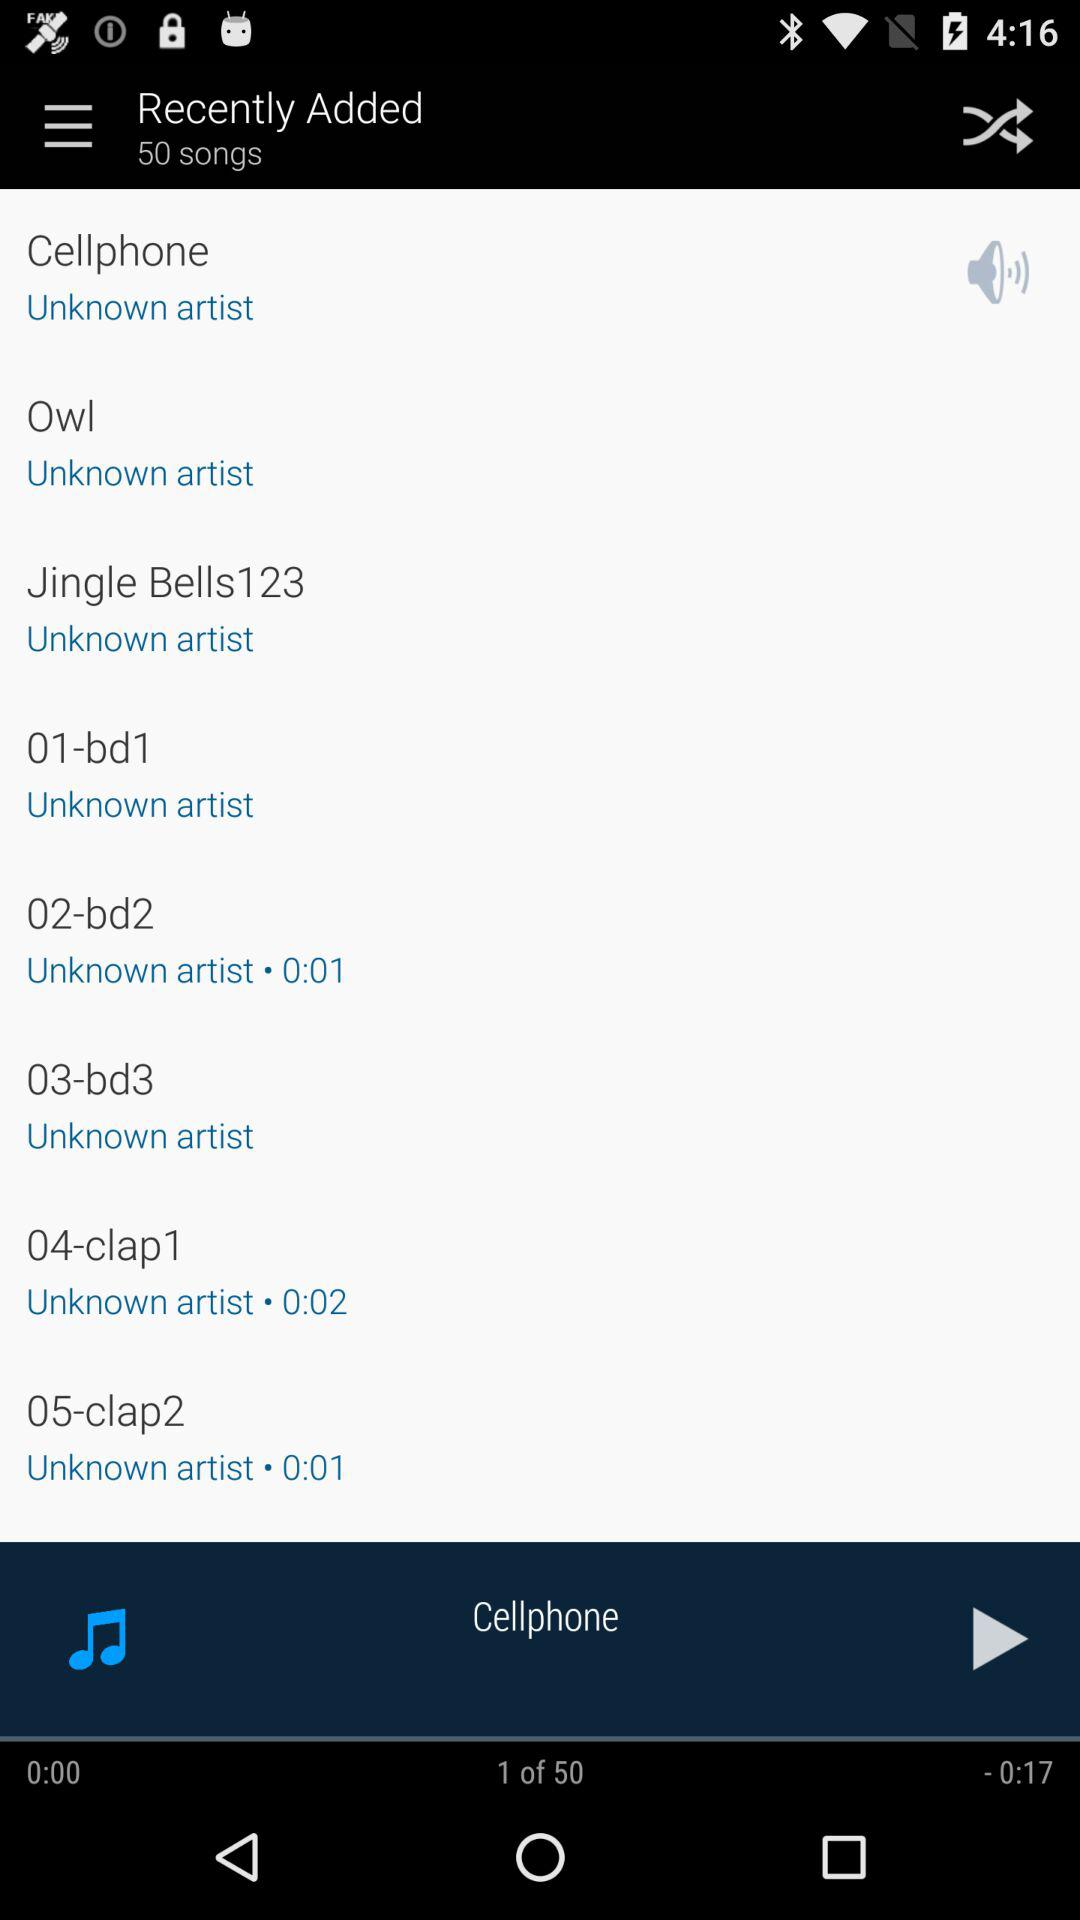What is the length of the song "04-clap1"? The length of the song "04-clap1" is 2 seconds. 